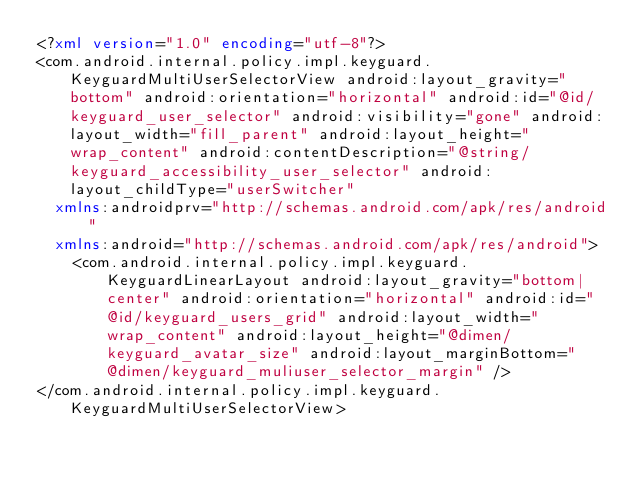Convert code to text. <code><loc_0><loc_0><loc_500><loc_500><_XML_><?xml version="1.0" encoding="utf-8"?>
<com.android.internal.policy.impl.keyguard.KeyguardMultiUserSelectorView android:layout_gravity="bottom" android:orientation="horizontal" android:id="@id/keyguard_user_selector" android:visibility="gone" android:layout_width="fill_parent" android:layout_height="wrap_content" android:contentDescription="@string/keyguard_accessibility_user_selector" android:layout_childType="userSwitcher"
  xmlns:androidprv="http://schemas.android.com/apk/res/android"
  xmlns:android="http://schemas.android.com/apk/res/android">
    <com.android.internal.policy.impl.keyguard.KeyguardLinearLayout android:layout_gravity="bottom|center" android:orientation="horizontal" android:id="@id/keyguard_users_grid" android:layout_width="wrap_content" android:layout_height="@dimen/keyguard_avatar_size" android:layout_marginBottom="@dimen/keyguard_muliuser_selector_margin" />
</com.android.internal.policy.impl.keyguard.KeyguardMultiUserSelectorView></code> 